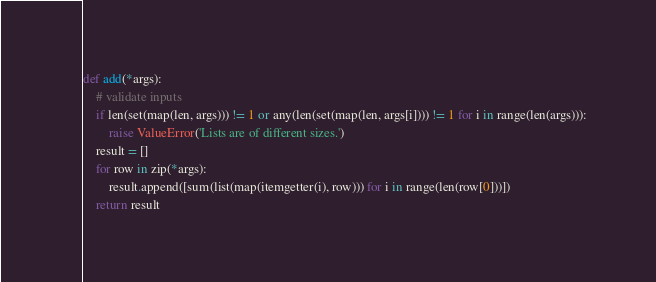Convert code to text. <code><loc_0><loc_0><loc_500><loc_500><_Python_>
def add(*args):
    # validate inputs
    if len(set(map(len, args))) != 1 or any(len(set(map(len, args[i]))) != 1 for i in range(len(args))):
        raise ValueError('Lists are of different sizes.')
    result = []
    for row in zip(*args):
        result.append([sum(list(map(itemgetter(i), row))) for i in range(len(row[0]))])
    return result
</code> 